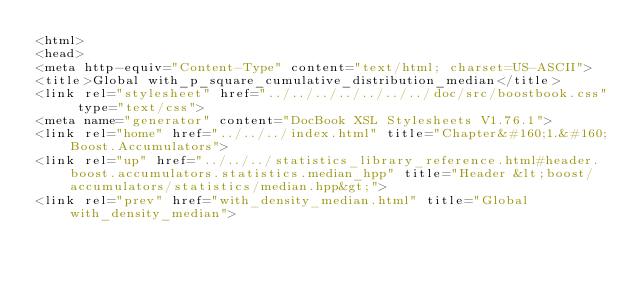<code> <loc_0><loc_0><loc_500><loc_500><_HTML_><html>
<head>
<meta http-equiv="Content-Type" content="text/html; charset=US-ASCII">
<title>Global with_p_square_cumulative_distribution_median</title>
<link rel="stylesheet" href="../../../../../../../doc/src/boostbook.css" type="text/css">
<meta name="generator" content="DocBook XSL Stylesheets V1.76.1">
<link rel="home" href="../../../index.html" title="Chapter&#160;1.&#160;Boost.Accumulators">
<link rel="up" href="../../../statistics_library_reference.html#header.boost.accumulators.statistics.median_hpp" title="Header &lt;boost/accumulators/statistics/median.hpp&gt;">
<link rel="prev" href="with_density_median.html" title="Global with_density_median"></code> 